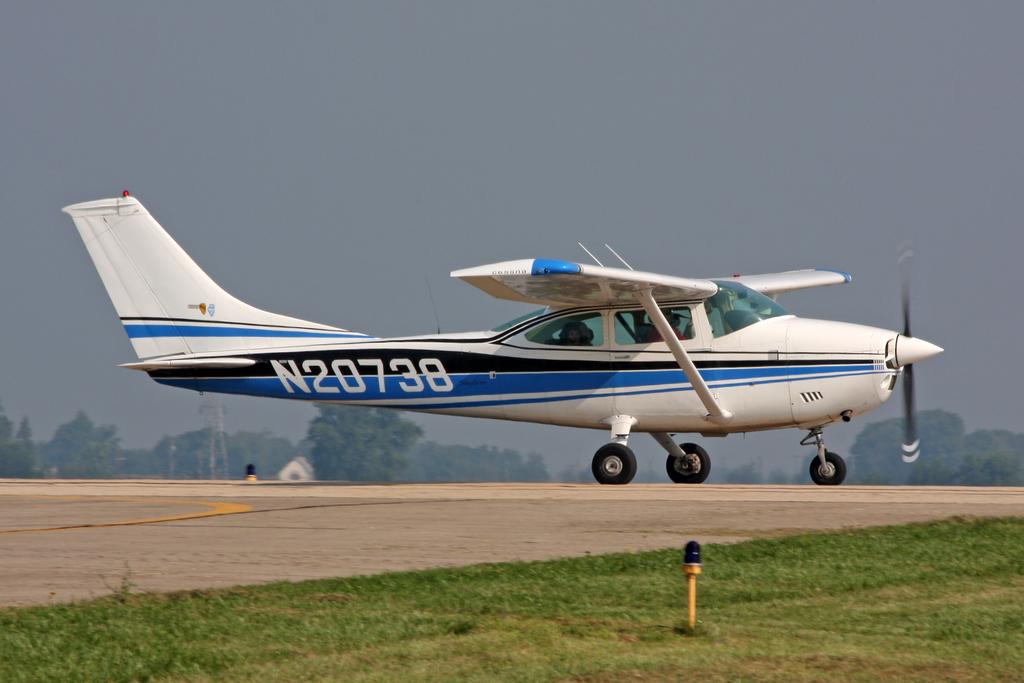What is the planes identification number?
Your answer should be very brief. N20738. 